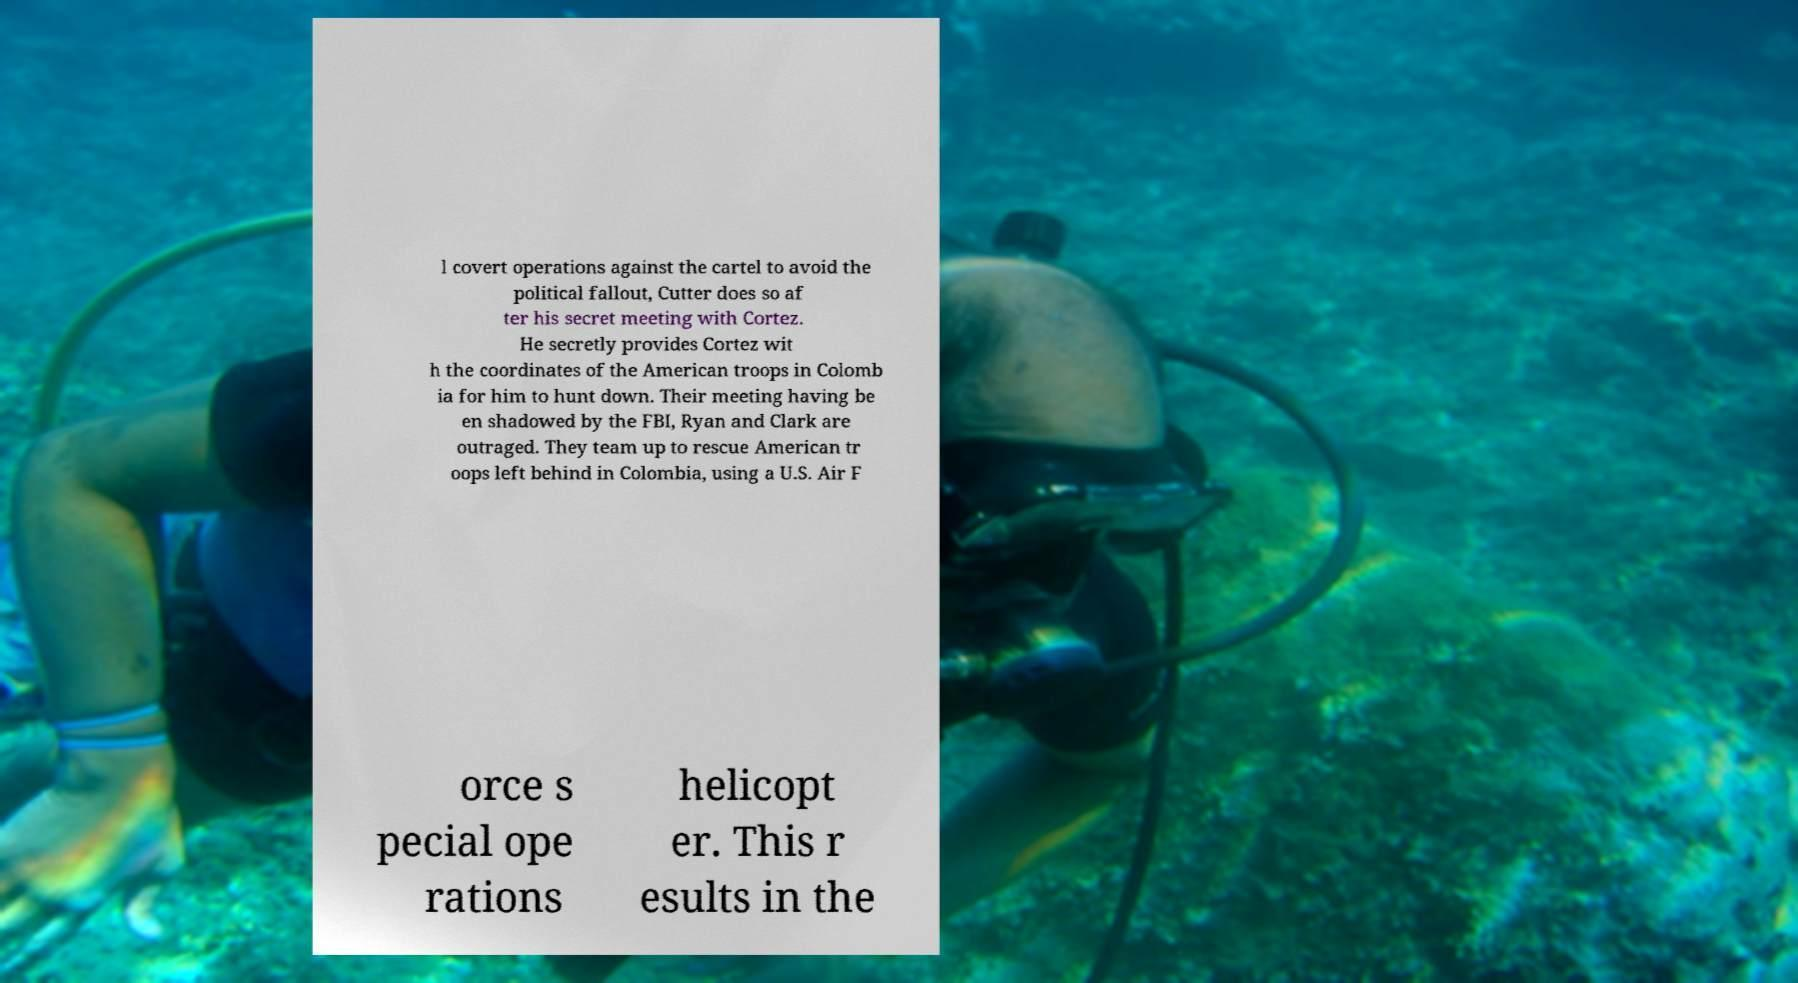Please identify and transcribe the text found in this image. l covert operations against the cartel to avoid the political fallout, Cutter does so af ter his secret meeting with Cortez. He secretly provides Cortez wit h the coordinates of the American troops in Colomb ia for him to hunt down. Their meeting having be en shadowed by the FBI, Ryan and Clark are outraged. They team up to rescue American tr oops left behind in Colombia, using a U.S. Air F orce s pecial ope rations helicopt er. This r esults in the 